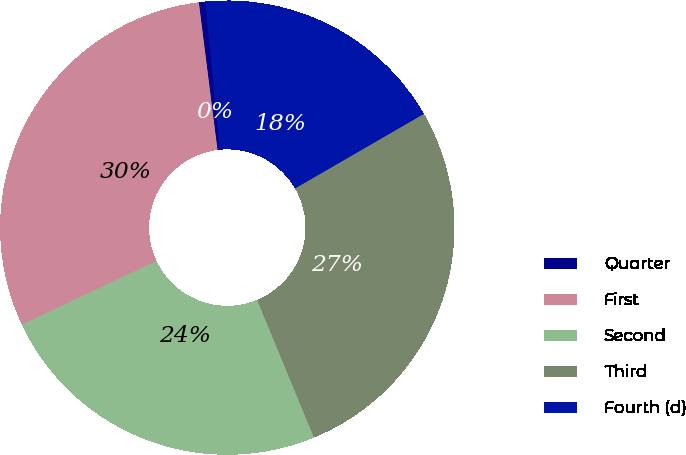Convert chart. <chart><loc_0><loc_0><loc_500><loc_500><pie_chart><fcel>Quarter<fcel>First<fcel>Second<fcel>Third<fcel>Fourth (d)<nl><fcel>0.46%<fcel>30.02%<fcel>24.21%<fcel>27.11%<fcel>18.19%<nl></chart> 